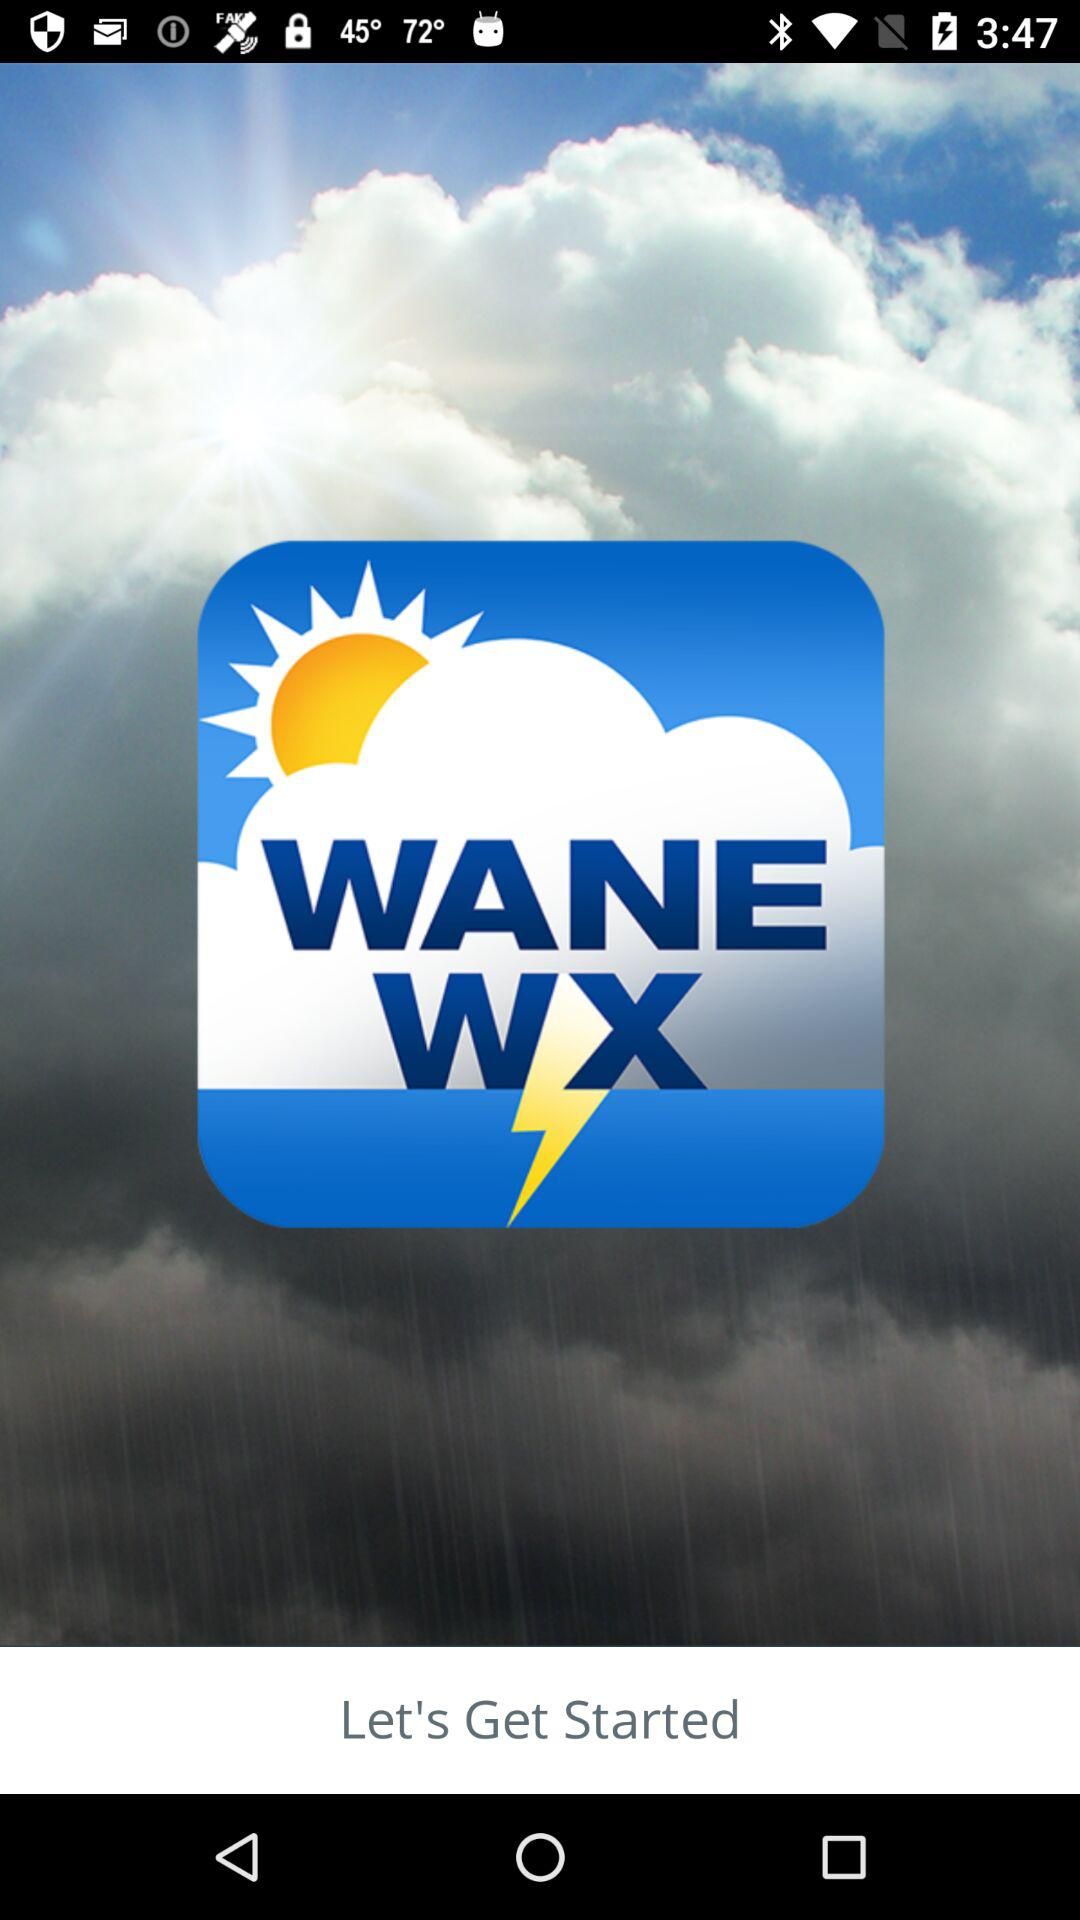What is the name of the application? The name of the application is "WANE WX". 